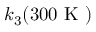Convert formula to latex. <formula><loc_0><loc_0><loc_500><loc_500>k _ { 3 } ( 3 0 0 K )</formula> 